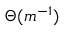<formula> <loc_0><loc_0><loc_500><loc_500>\Theta ( m ^ { - 1 } )</formula> 